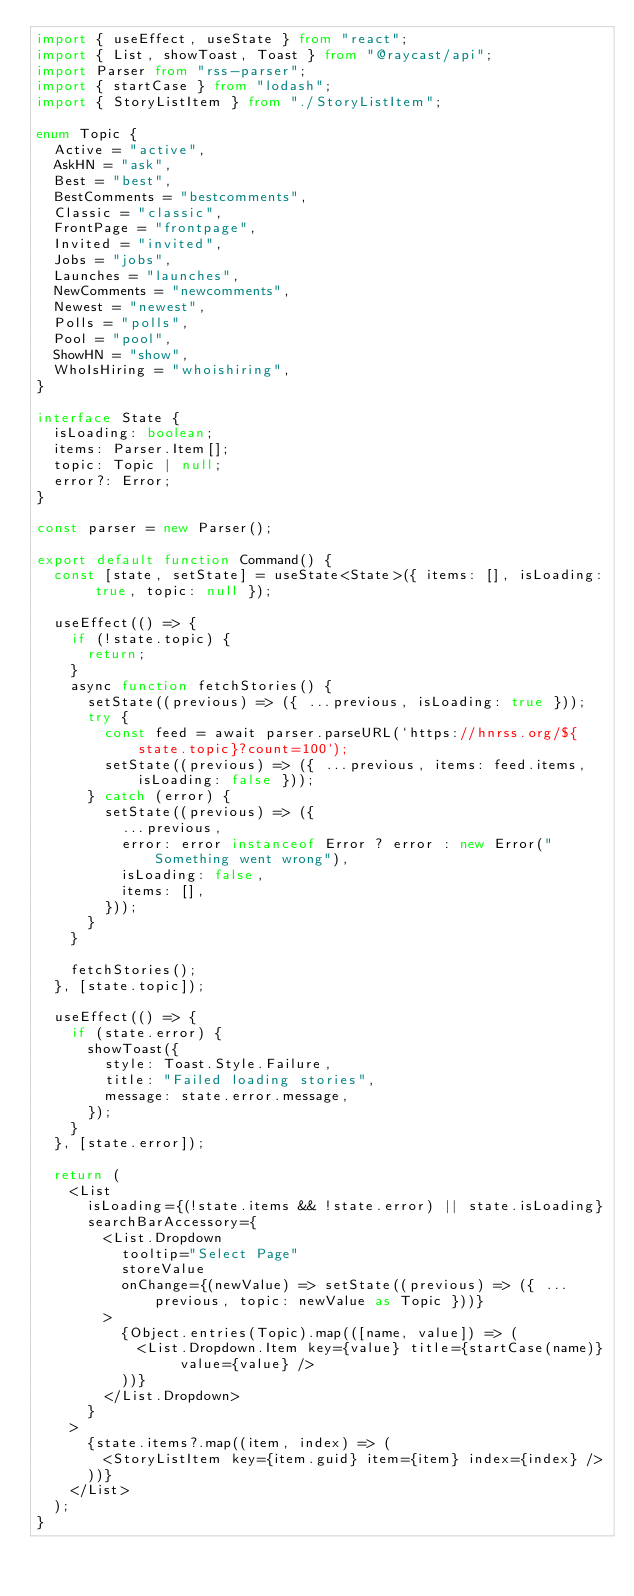<code> <loc_0><loc_0><loc_500><loc_500><_TypeScript_>import { useEffect, useState } from "react";
import { List, showToast, Toast } from "@raycast/api";
import Parser from "rss-parser";
import { startCase } from "lodash";
import { StoryListItem } from "./StoryListItem";

enum Topic {
  Active = "active",
  AskHN = "ask",
  Best = "best",
  BestComments = "bestcomments",
  Classic = "classic",
  FrontPage = "frontpage",
  Invited = "invited",
  Jobs = "jobs",
  Launches = "launches",
  NewComments = "newcomments",
  Newest = "newest",
  Polls = "polls",
  Pool = "pool",
  ShowHN = "show",
  WhoIsHiring = "whoishiring",
}

interface State {
  isLoading: boolean;
  items: Parser.Item[];
  topic: Topic | null;
  error?: Error;
}

const parser = new Parser();

export default function Command() {
  const [state, setState] = useState<State>({ items: [], isLoading: true, topic: null });

  useEffect(() => {
    if (!state.topic) {
      return;
    }
    async function fetchStories() {
      setState((previous) => ({ ...previous, isLoading: true }));
      try {
        const feed = await parser.parseURL(`https://hnrss.org/${state.topic}?count=100`);
        setState((previous) => ({ ...previous, items: feed.items, isLoading: false }));
      } catch (error) {
        setState((previous) => ({
          ...previous,
          error: error instanceof Error ? error : new Error("Something went wrong"),
          isLoading: false,
          items: [],
        }));
      }
    }

    fetchStories();
  }, [state.topic]);

  useEffect(() => {
    if (state.error) {
      showToast({
        style: Toast.Style.Failure,
        title: "Failed loading stories",
        message: state.error.message,
      });
    }
  }, [state.error]);

  return (
    <List
      isLoading={(!state.items && !state.error) || state.isLoading}
      searchBarAccessory={
        <List.Dropdown
          tooltip="Select Page"
          storeValue
          onChange={(newValue) => setState((previous) => ({ ...previous, topic: newValue as Topic }))}
        >
          {Object.entries(Topic).map(([name, value]) => (
            <List.Dropdown.Item key={value} title={startCase(name)} value={value} />
          ))}
        </List.Dropdown>
      }
    >
      {state.items?.map((item, index) => (
        <StoryListItem key={item.guid} item={item} index={index} />
      ))}
    </List>
  );
}
</code> 